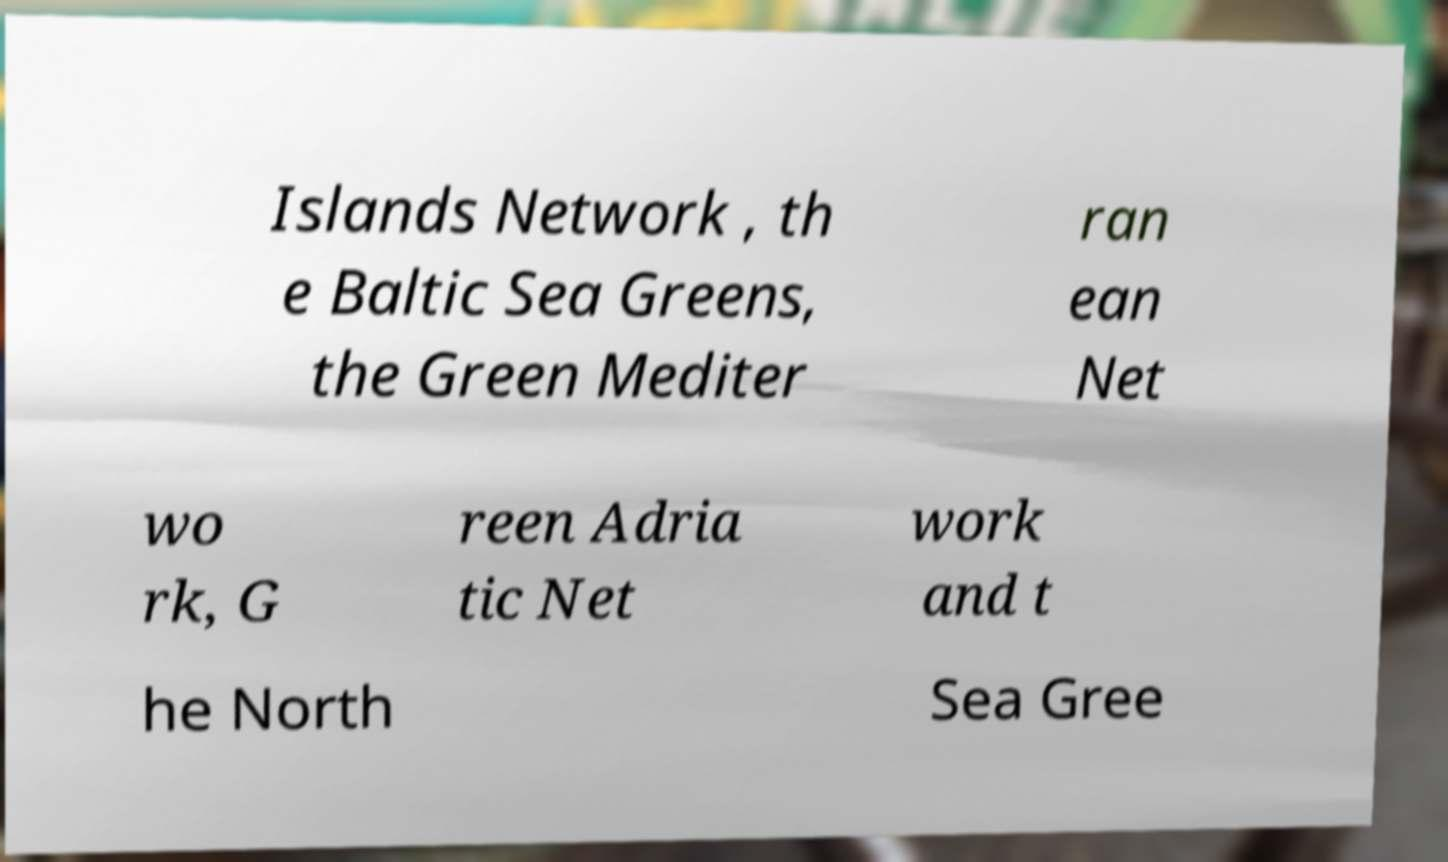Please identify and transcribe the text found in this image. Islands Network , th e Baltic Sea Greens, the Green Mediter ran ean Net wo rk, G reen Adria tic Net work and t he North Sea Gree 